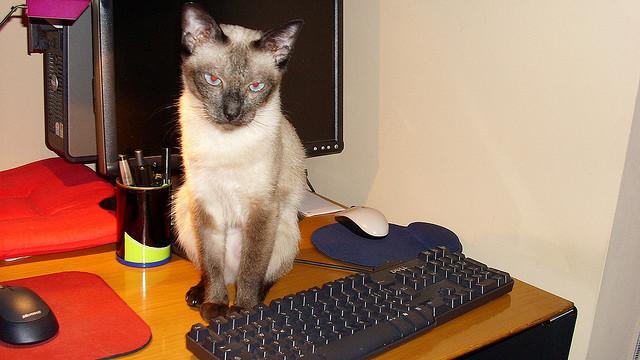What shape is the red mouse pad?
Concise answer only. Square. What color are the walls?
Write a very short answer. White. What type of cat is on the desk?
Be succinct. Siamese. 